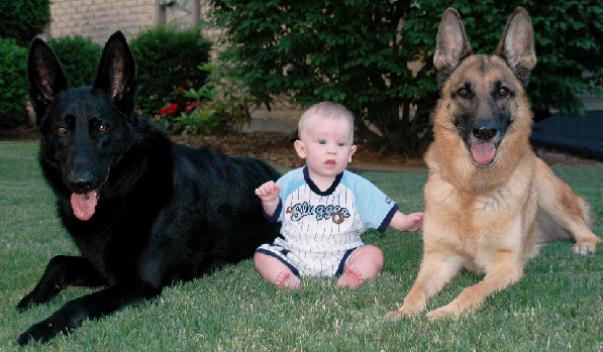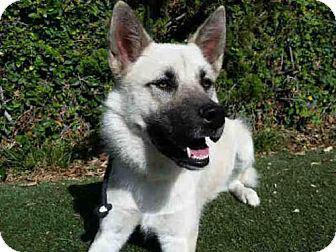The first image is the image on the left, the second image is the image on the right. For the images shown, is this caption "There are at least two dogs in the left image." true? Answer yes or no. Yes. The first image is the image on the left, the second image is the image on the right. Given the left and right images, does the statement "There are two dogs together outside in the image on the left." hold true? Answer yes or no. Yes. 